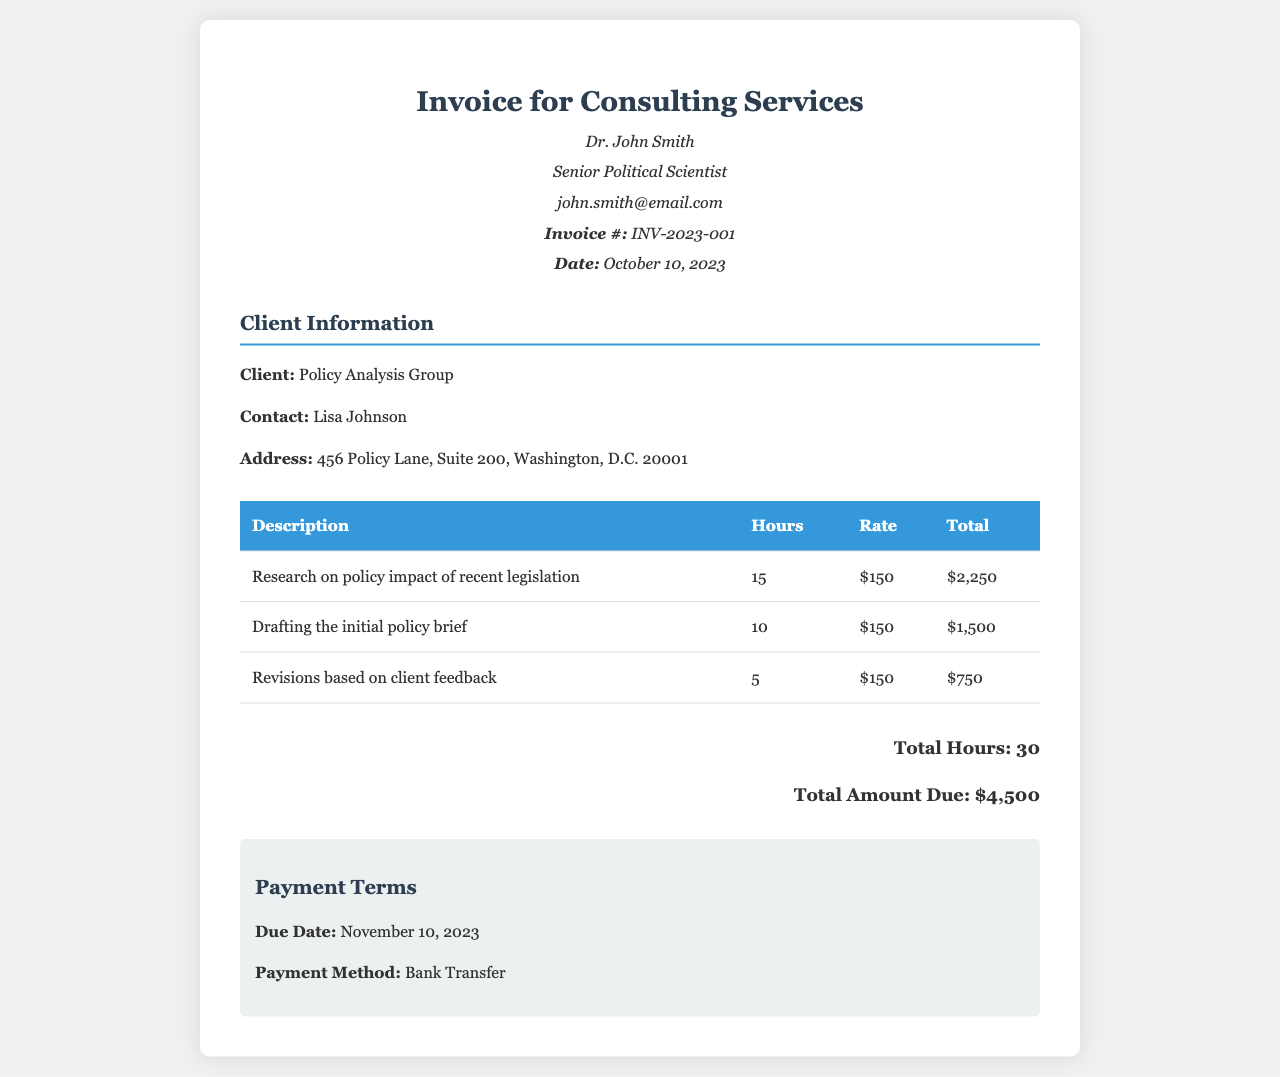What is the invoice number? The invoice number is clearly stated in the document as INV-2023-001.
Answer: INV-2023-001 Who is the client? The client's name is mentioned in the document as Policy Analysis Group.
Answer: Policy Analysis Group What is the total amount due? The total amount due is outlined in the document and sums up to $4,500.
Answer: $4,500 How many hours were spent on research? The document specifies that 15 hours were spent on research.
Answer: 15 What is the due date for payment? The due date is explicitly mentioned as November 10, 2023.
Answer: November 10, 2023 What is the hourly rate for the consulting services? The document states that the hourly rate is $150.
Answer: $150 What service had the least hours billed? The service with the least hours billed is revisions based on client feedback at 5 hours.
Answer: revisions based on client feedback What was the total number of hours billed? The document aggregates the hours spent and shows a total of 30 hours billed.
Answer: 30 